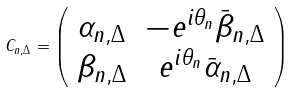<formula> <loc_0><loc_0><loc_500><loc_500>C _ { n , \Delta } = \left ( \begin{array} { c c } \alpha _ { n , \Delta } & - e ^ { i \theta _ { n } } \bar { \beta } _ { n , \Delta } \\ \beta _ { n , \Delta } & e ^ { i \theta _ { n } } \bar { \alpha } _ { n , \Delta } \end{array} \right )</formula> 